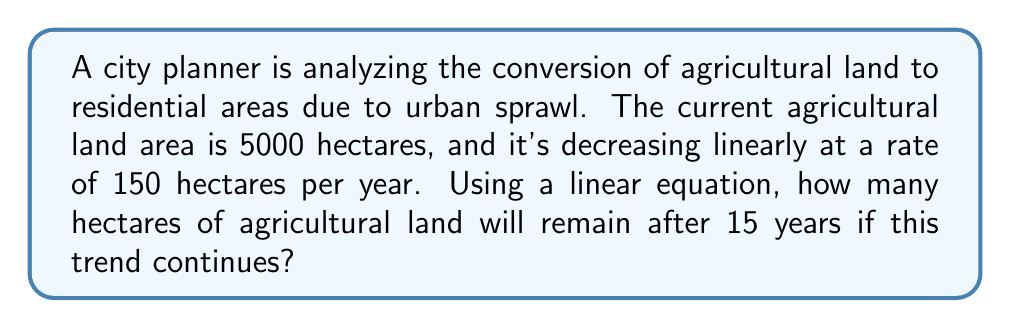Teach me how to tackle this problem. Let's approach this step-by-step:

1) We can represent the agricultural land area as a function of time using a linear equation:
   $$ A(t) = A_0 - rt $$
   Where:
   $A(t)$ is the area at time $t$
   $A_0$ is the initial area
   $r$ is the rate of decrease
   $t$ is the time in years

2) We know:
   $A_0 = 5000$ hectares (initial area)
   $r = 150$ hectares/year (rate of decrease)
   $t = 15$ years (time we're interested in)

3) Substituting these values into our equation:
   $$ A(15) = 5000 - 150(15) $$

4) Simplify:
   $$ A(15) = 5000 - 2250 $$

5) Calculate the final result:
   $$ A(15) = 2750 $$

Therefore, after 15 years, 2750 hectares of agricultural land will remain.
Answer: 2750 hectares 